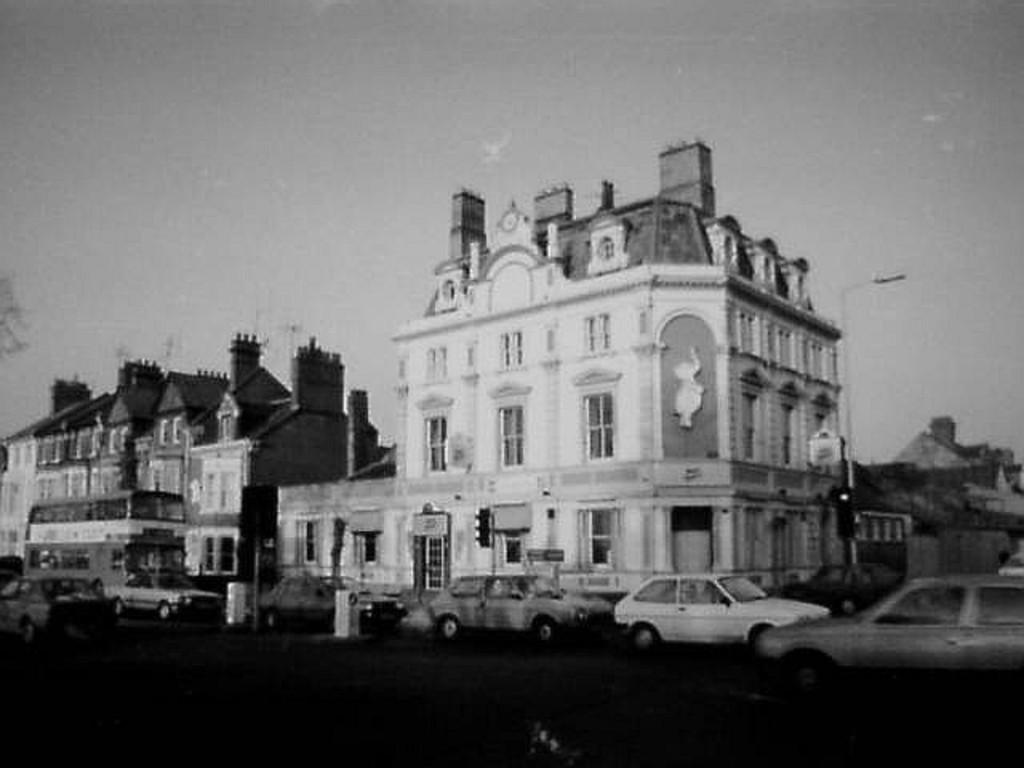What is the color scheme of the image? The image is black and white. What type of structures can be seen in the image? There are buildings in the image. What is present on the road in the image? There are vehicles on the road in the image. What architectural features are visible in the image? There are windows and poles visible in the image. What else can be seen in the image besides buildings and vehicles? There are boards in the image. What part of the natural environment is visible in the image? The sky is visible in the image. How many stitches are used to create the ground in the image? There are no stitches present in the image, as it is a photograph and not a fabric or textile. What type of ground is visible in the image? The ground in the image is a road, as mentioned in the fact that there are vehicles on the road. 